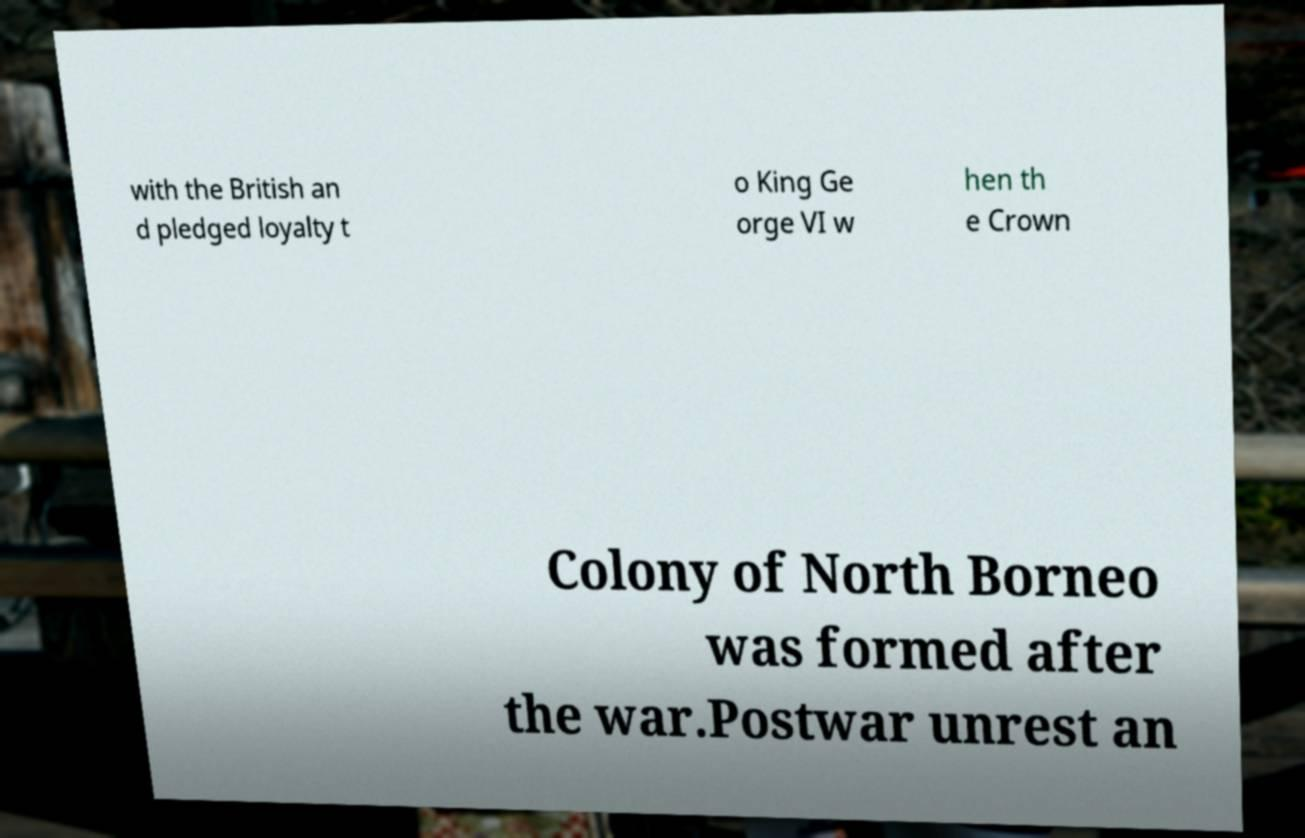For documentation purposes, I need the text within this image transcribed. Could you provide that? with the British an d pledged loyalty t o King Ge orge VI w hen th e Crown Colony of North Borneo was formed after the war.Postwar unrest an 